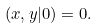Convert formula to latex. <formula><loc_0><loc_0><loc_500><loc_500>( x , y | 0 ) = 0 .</formula> 